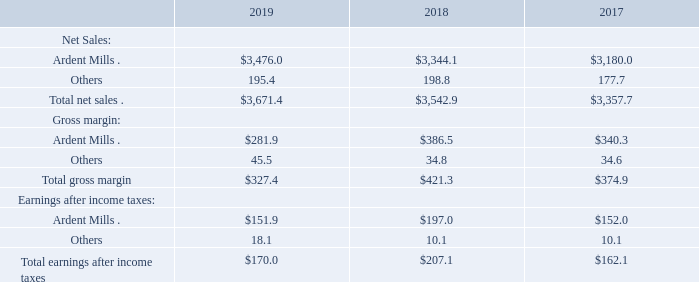7. INVESTMENTS IN JOINT VENTURES
The total carrying value of our equity method investments at the end of fiscal 2019 and 2018 was $796.3 million and $776.2 million, respectively. These amounts are included in other assets and reflect our 44% ownership interest in Ardent Mills and 50% ownership interests in other joint ventures. Due to differences in fiscal reporting periods, we recognized the equity method investment earnings on a lag of approximately one month.
In fiscal 2019, we had purchases from our equity method investees of $39.4 million. Total dividends received from equity method investments in fiscal 2019 were $55.0 million.
In fiscal 2018, we had purchases from our equity method investees of $34.9 million. Total dividends received from equity method investments in fiscal 2018 were $62.5 million.
In fiscal 2017, we had purchases from our equity method investees of $41.8 million. Total dividends received from equity method investments in fiscal 2017 were $68.2 million.
Notes to Consolidated Financial Statements - (Continued) Fiscal Years Ended May 26, 2019, May 27, 2018, and May 28, 2017 (columnar dollars in millions except per share amounts) Summarized combined financial information for our equity method investments on a 100% basis is as follows:
What was the value of equity that the company purchased during fiscal 2019? $39.4 million. How much dividends that the company received from equity method investments in fiscal 2017, 2018, and 2019, respectively? $68.2 million, $62.5 million, $55.0 million. What was the net sales from Ardent Mills in fiscal 2018?
Answer scale should be: million. $3,344.1. What is the ratio of dividends that the company received from equity method investments to total earning after income taxes in fiscal 2019? 55.0/170.0 
Answer: 0.32. What is the average of Ardent Mills’ net sales from 2017 to 2019? 
Answer scale should be: million. (3,476.0+3,344.1+3,180.0)/3 
Answer: 3333.37. What is Ardent Mills’ gross profit margin ratio for the fiscal year 2017? 340.3/3,180.0 
Answer: 0.11. 